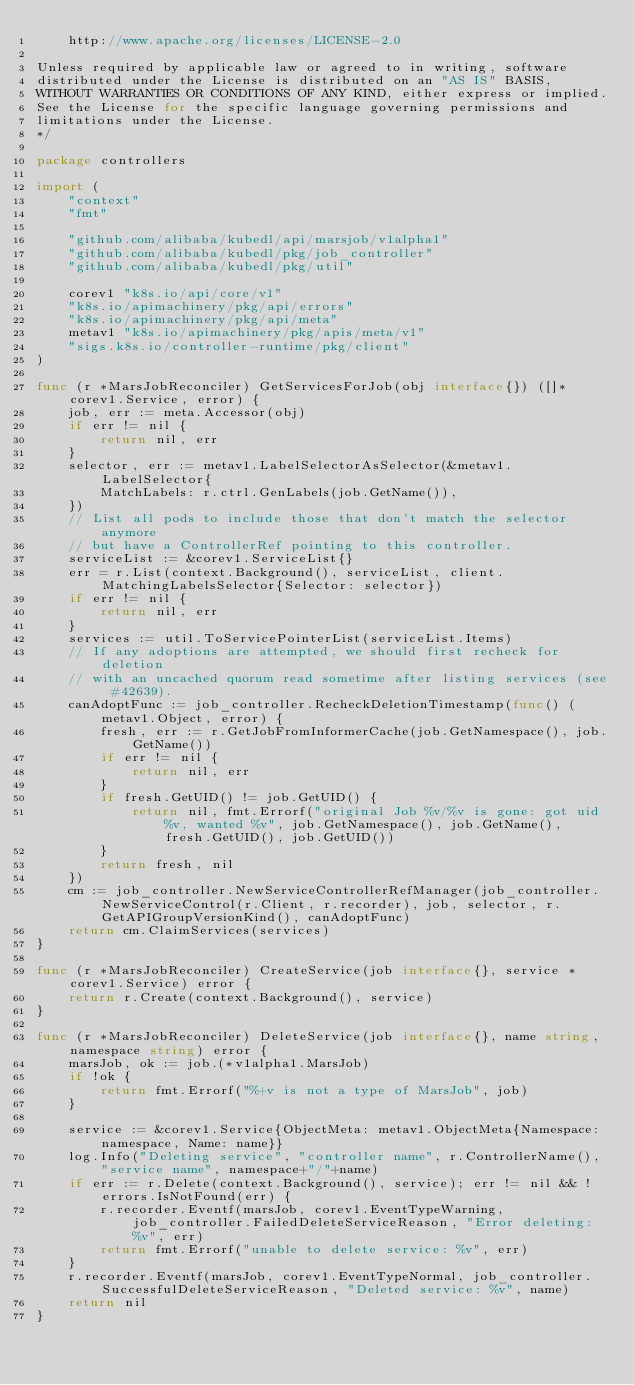Convert code to text. <code><loc_0><loc_0><loc_500><loc_500><_Go_>    http://www.apache.org/licenses/LICENSE-2.0

Unless required by applicable law or agreed to in writing, software
distributed under the License is distributed on an "AS IS" BASIS,
WITHOUT WARRANTIES OR CONDITIONS OF ANY KIND, either express or implied.
See the License for the specific language governing permissions and
limitations under the License.
*/

package controllers

import (
	"context"
	"fmt"

	"github.com/alibaba/kubedl/api/marsjob/v1alpha1"
	"github.com/alibaba/kubedl/pkg/job_controller"
	"github.com/alibaba/kubedl/pkg/util"

	corev1 "k8s.io/api/core/v1"
	"k8s.io/apimachinery/pkg/api/errors"
	"k8s.io/apimachinery/pkg/api/meta"
	metav1 "k8s.io/apimachinery/pkg/apis/meta/v1"
	"sigs.k8s.io/controller-runtime/pkg/client"
)

func (r *MarsJobReconciler) GetServicesForJob(obj interface{}) ([]*corev1.Service, error) {
	job, err := meta.Accessor(obj)
	if err != nil {
		return nil, err
	}
	selector, err := metav1.LabelSelectorAsSelector(&metav1.LabelSelector{
		MatchLabels: r.ctrl.GenLabels(job.GetName()),
	})
	// List all pods to include those that don't match the selector anymore
	// but have a ControllerRef pointing to this controller.
	serviceList := &corev1.ServiceList{}
	err = r.List(context.Background(), serviceList, client.MatchingLabelsSelector{Selector: selector})
	if err != nil {
		return nil, err
	}
	services := util.ToServicePointerList(serviceList.Items)
	// If any adoptions are attempted, we should first recheck for deletion
	// with an uncached quorum read sometime after listing services (see #42639).
	canAdoptFunc := job_controller.RecheckDeletionTimestamp(func() (metav1.Object, error) {
		fresh, err := r.GetJobFromInformerCache(job.GetNamespace(), job.GetName())
		if err != nil {
			return nil, err
		}
		if fresh.GetUID() != job.GetUID() {
			return nil, fmt.Errorf("original Job %v/%v is gone: got uid %v, wanted %v", job.GetNamespace(), job.GetName(), fresh.GetUID(), job.GetUID())
		}
		return fresh, nil
	})
	cm := job_controller.NewServiceControllerRefManager(job_controller.NewServiceControl(r.Client, r.recorder), job, selector, r.GetAPIGroupVersionKind(), canAdoptFunc)
	return cm.ClaimServices(services)
}

func (r *MarsJobReconciler) CreateService(job interface{}, service *corev1.Service) error {
	return r.Create(context.Background(), service)
}

func (r *MarsJobReconciler) DeleteService(job interface{}, name string, namespace string) error {
	marsJob, ok := job.(*v1alpha1.MarsJob)
	if !ok {
		return fmt.Errorf("%+v is not a type of MarsJob", job)
	}

	service := &corev1.Service{ObjectMeta: metav1.ObjectMeta{Namespace: namespace, Name: name}}
	log.Info("Deleting service", "controller name", r.ControllerName(), "service name", namespace+"/"+name)
	if err := r.Delete(context.Background(), service); err != nil && !errors.IsNotFound(err) {
		r.recorder.Eventf(marsJob, corev1.EventTypeWarning, job_controller.FailedDeleteServiceReason, "Error deleting: %v", err)
		return fmt.Errorf("unable to delete service: %v", err)
	}
	r.recorder.Eventf(marsJob, corev1.EventTypeNormal, job_controller.SuccessfulDeleteServiceReason, "Deleted service: %v", name)
	return nil
}
</code> 